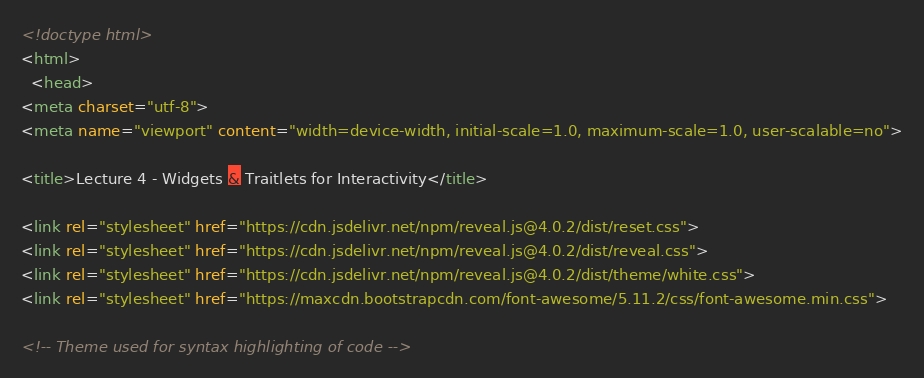<code> <loc_0><loc_0><loc_500><loc_500><_HTML_><!doctype html>
<html>
  <head>
<meta charset="utf-8">
<meta name="viewport" content="width=device-width, initial-scale=1.0, maximum-scale=1.0, user-scalable=no">

<title>Lecture 4 - Widgets & Traitlets for Interactivity</title>

<link rel="stylesheet" href="https://cdn.jsdelivr.net/npm/reveal.js@4.0.2/dist/reset.css">
<link rel="stylesheet" href="https://cdn.jsdelivr.net/npm/reveal.js@4.0.2/dist/reveal.css">
<link rel="stylesheet" href="https://cdn.jsdelivr.net/npm/reveal.js@4.0.2/dist/theme/white.css">
<link rel="stylesheet" href="https://maxcdn.bootstrapcdn.com/font-awesome/5.11.2/css/font-awesome.min.css">

<!-- Theme used for syntax highlighting of code --></code> 